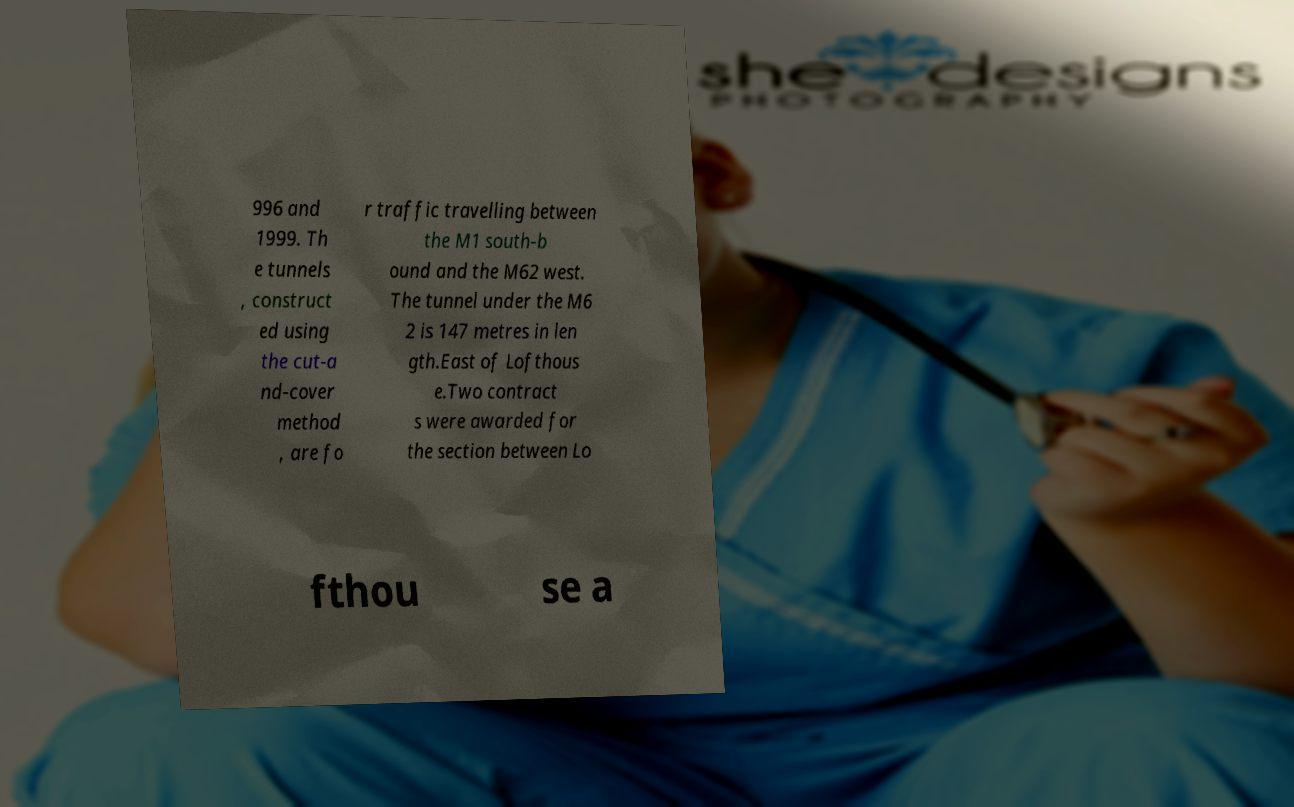What messages or text are displayed in this image? I need them in a readable, typed format. 996 and 1999. Th e tunnels , construct ed using the cut-a nd-cover method , are fo r traffic travelling between the M1 south-b ound and the M62 west. The tunnel under the M6 2 is 147 metres in len gth.East of Lofthous e.Two contract s were awarded for the section between Lo fthou se a 